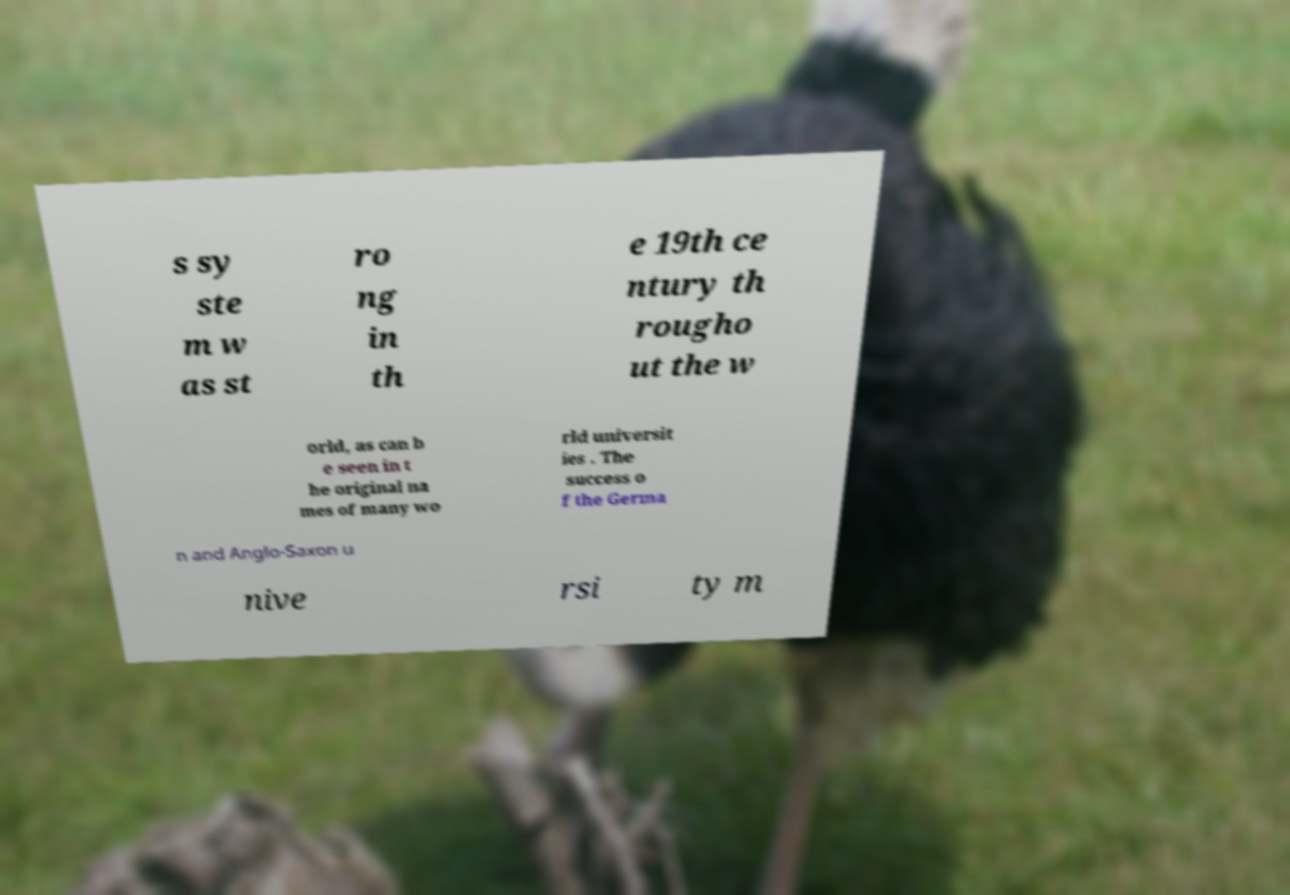Can you read and provide the text displayed in the image?This photo seems to have some interesting text. Can you extract and type it out for me? s sy ste m w as st ro ng in th e 19th ce ntury th rougho ut the w orld, as can b e seen in t he original na mes of many wo rld universit ies . The success o f the Germa n and Anglo-Saxon u nive rsi ty m 